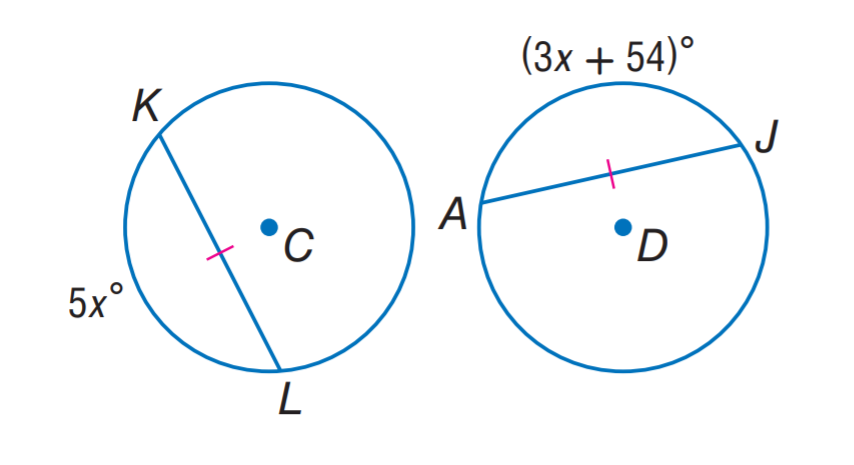Question: \odot C \cong \odot D. Find x.
Choices:
A. 13.5
B. 27
C. 54
D. 108
Answer with the letter. Answer: B 